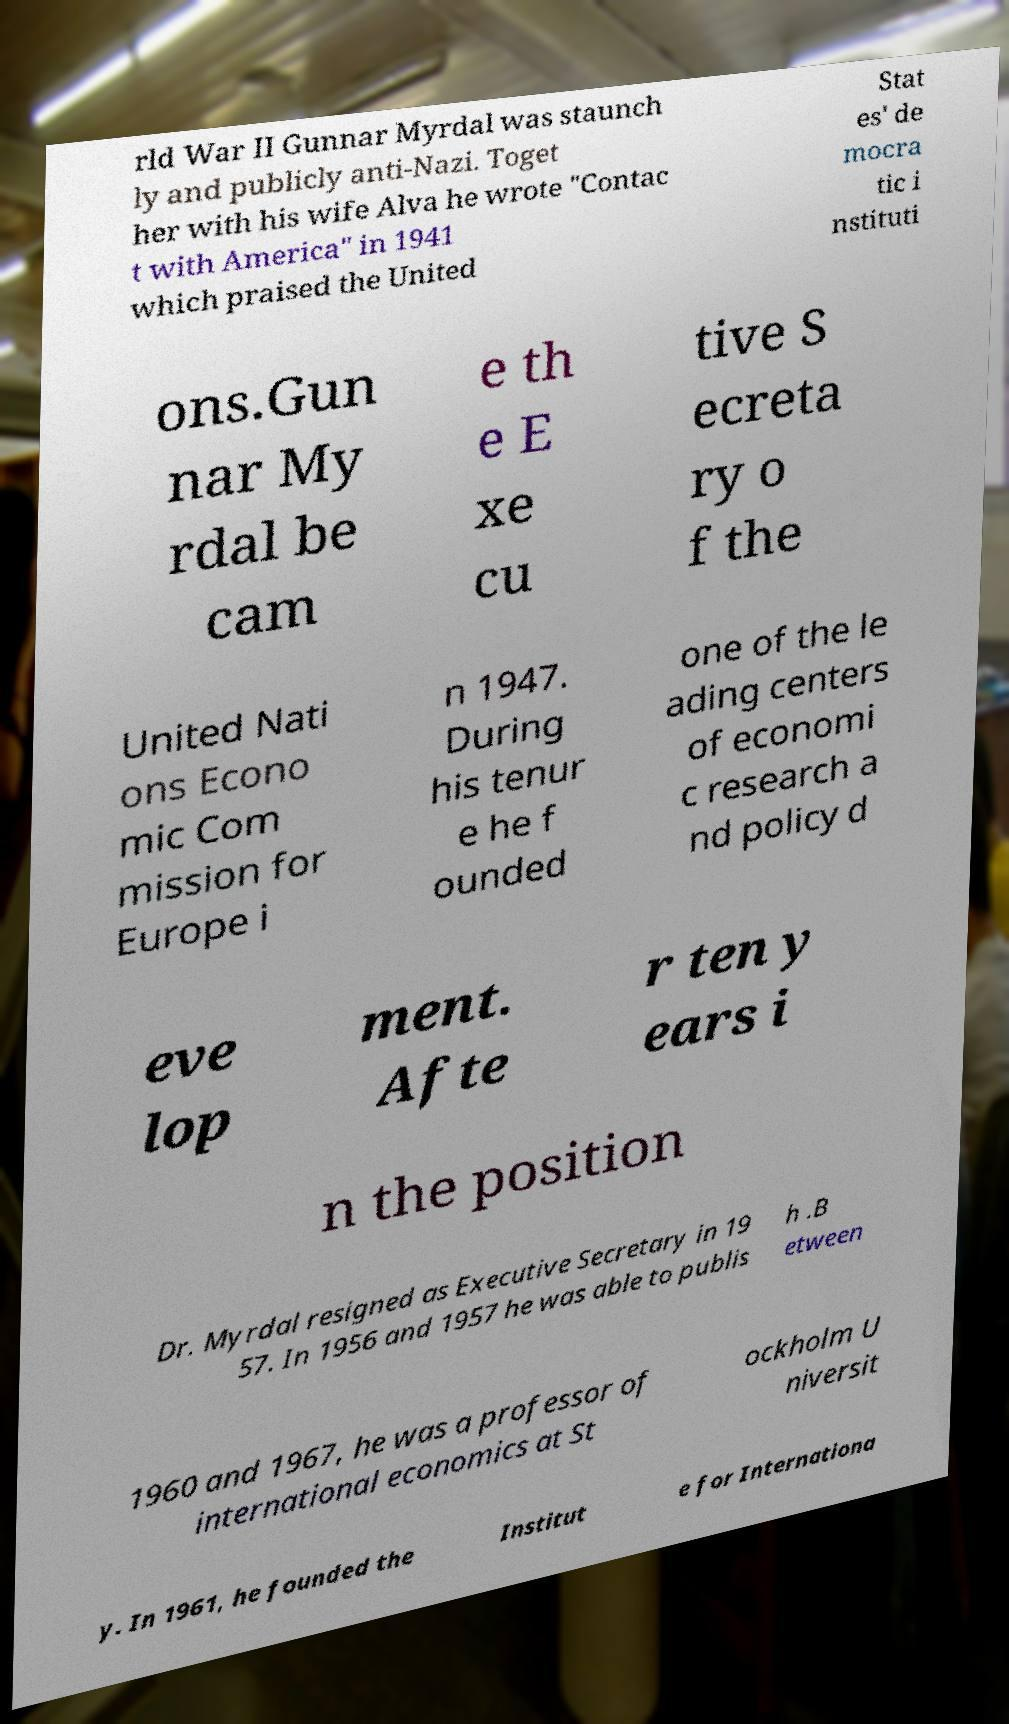For documentation purposes, I need the text within this image transcribed. Could you provide that? rld War II Gunnar Myrdal was staunch ly and publicly anti-Nazi. Toget her with his wife Alva he wrote "Contac t with America" in 1941 which praised the United Stat es' de mocra tic i nstituti ons.Gun nar My rdal be cam e th e E xe cu tive S ecreta ry o f the United Nati ons Econo mic Com mission for Europe i n 1947. During his tenur e he f ounded one of the le ading centers of economi c research a nd policy d eve lop ment. Afte r ten y ears i n the position Dr. Myrdal resigned as Executive Secretary in 19 57. In 1956 and 1957 he was able to publis h .B etween 1960 and 1967, he was a professor of international economics at St ockholm U niversit y. In 1961, he founded the Institut e for Internationa 